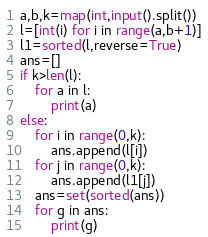<code> <loc_0><loc_0><loc_500><loc_500><_Python_>a,b,k=map(int,input().split())
l=[int(i) for i in range(a,b+1)]
l1=sorted(l,reverse=True)
ans=[]
if k>len(l):
    for a in l:
        print(a)
else:
    for i in range(0,k):
        ans.append(l[i])
    for j in range(0,k):
        ans.append(l1[j])
    ans=set(sorted(ans))
    for g in ans:
        print(g)</code> 